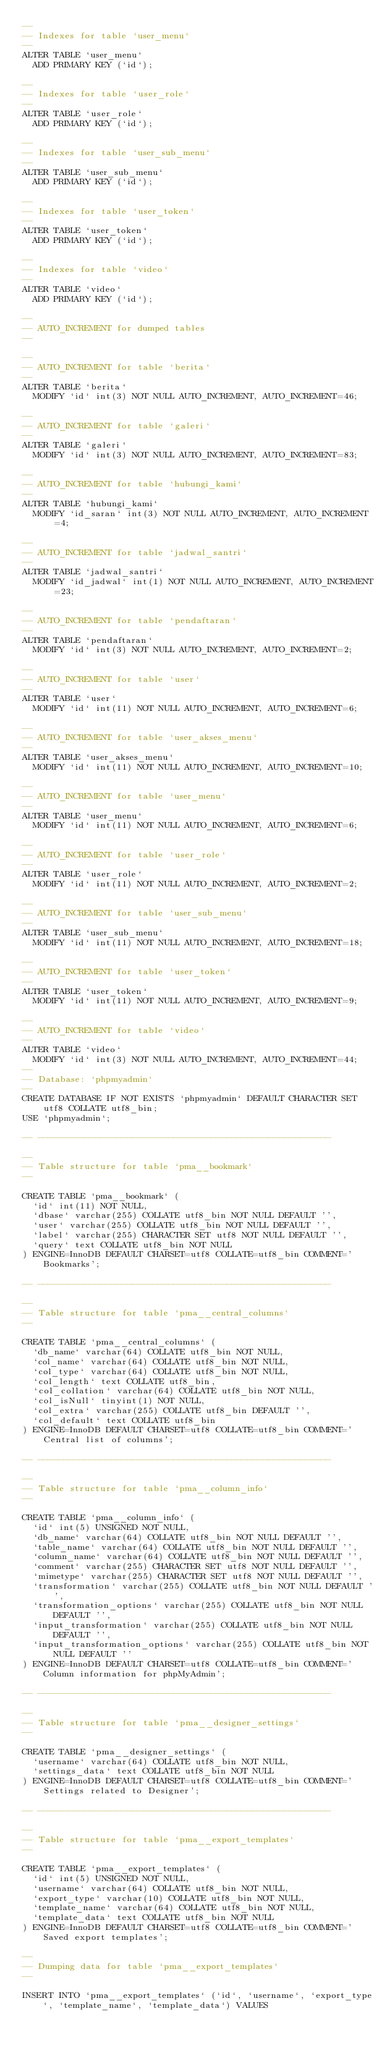<code> <loc_0><loc_0><loc_500><loc_500><_SQL_>--
-- Indexes for table `user_menu`
--
ALTER TABLE `user_menu`
  ADD PRIMARY KEY (`id`);

--
-- Indexes for table `user_role`
--
ALTER TABLE `user_role`
  ADD PRIMARY KEY (`id`);

--
-- Indexes for table `user_sub_menu`
--
ALTER TABLE `user_sub_menu`
  ADD PRIMARY KEY (`id`);

--
-- Indexes for table `user_token`
--
ALTER TABLE `user_token`
  ADD PRIMARY KEY (`id`);

--
-- Indexes for table `video`
--
ALTER TABLE `video`
  ADD PRIMARY KEY (`id`);

--
-- AUTO_INCREMENT for dumped tables
--

--
-- AUTO_INCREMENT for table `berita`
--
ALTER TABLE `berita`
  MODIFY `id` int(3) NOT NULL AUTO_INCREMENT, AUTO_INCREMENT=46;

--
-- AUTO_INCREMENT for table `galeri`
--
ALTER TABLE `galeri`
  MODIFY `id` int(3) NOT NULL AUTO_INCREMENT, AUTO_INCREMENT=83;

--
-- AUTO_INCREMENT for table `hubungi_kami`
--
ALTER TABLE `hubungi_kami`
  MODIFY `id_saran` int(3) NOT NULL AUTO_INCREMENT, AUTO_INCREMENT=4;

--
-- AUTO_INCREMENT for table `jadwal_santri`
--
ALTER TABLE `jadwal_santri`
  MODIFY `id_jadwal` int(1) NOT NULL AUTO_INCREMENT, AUTO_INCREMENT=23;

--
-- AUTO_INCREMENT for table `pendaftaran`
--
ALTER TABLE `pendaftaran`
  MODIFY `id` int(3) NOT NULL AUTO_INCREMENT, AUTO_INCREMENT=2;

--
-- AUTO_INCREMENT for table `user`
--
ALTER TABLE `user`
  MODIFY `id` int(11) NOT NULL AUTO_INCREMENT, AUTO_INCREMENT=6;

--
-- AUTO_INCREMENT for table `user_akses_menu`
--
ALTER TABLE `user_akses_menu`
  MODIFY `id` int(11) NOT NULL AUTO_INCREMENT, AUTO_INCREMENT=10;

--
-- AUTO_INCREMENT for table `user_menu`
--
ALTER TABLE `user_menu`
  MODIFY `id` int(11) NOT NULL AUTO_INCREMENT, AUTO_INCREMENT=6;

--
-- AUTO_INCREMENT for table `user_role`
--
ALTER TABLE `user_role`
  MODIFY `id` int(11) NOT NULL AUTO_INCREMENT, AUTO_INCREMENT=2;

--
-- AUTO_INCREMENT for table `user_sub_menu`
--
ALTER TABLE `user_sub_menu`
  MODIFY `id` int(11) NOT NULL AUTO_INCREMENT, AUTO_INCREMENT=18;

--
-- AUTO_INCREMENT for table `user_token`
--
ALTER TABLE `user_token`
  MODIFY `id` int(11) NOT NULL AUTO_INCREMENT, AUTO_INCREMENT=9;

--
-- AUTO_INCREMENT for table `video`
--
ALTER TABLE `video`
  MODIFY `id` int(3) NOT NULL AUTO_INCREMENT, AUTO_INCREMENT=44;
--
-- Database: `phpmyadmin`
--
CREATE DATABASE IF NOT EXISTS `phpmyadmin` DEFAULT CHARACTER SET utf8 COLLATE utf8_bin;
USE `phpmyadmin`;

-- --------------------------------------------------------

--
-- Table structure for table `pma__bookmark`
--

CREATE TABLE `pma__bookmark` (
  `id` int(11) NOT NULL,
  `dbase` varchar(255) COLLATE utf8_bin NOT NULL DEFAULT '',
  `user` varchar(255) COLLATE utf8_bin NOT NULL DEFAULT '',
  `label` varchar(255) CHARACTER SET utf8 NOT NULL DEFAULT '',
  `query` text COLLATE utf8_bin NOT NULL
) ENGINE=InnoDB DEFAULT CHARSET=utf8 COLLATE=utf8_bin COMMENT='Bookmarks';

-- --------------------------------------------------------

--
-- Table structure for table `pma__central_columns`
--

CREATE TABLE `pma__central_columns` (
  `db_name` varchar(64) COLLATE utf8_bin NOT NULL,
  `col_name` varchar(64) COLLATE utf8_bin NOT NULL,
  `col_type` varchar(64) COLLATE utf8_bin NOT NULL,
  `col_length` text COLLATE utf8_bin,
  `col_collation` varchar(64) COLLATE utf8_bin NOT NULL,
  `col_isNull` tinyint(1) NOT NULL,
  `col_extra` varchar(255) COLLATE utf8_bin DEFAULT '',
  `col_default` text COLLATE utf8_bin
) ENGINE=InnoDB DEFAULT CHARSET=utf8 COLLATE=utf8_bin COMMENT='Central list of columns';

-- --------------------------------------------------------

--
-- Table structure for table `pma__column_info`
--

CREATE TABLE `pma__column_info` (
  `id` int(5) UNSIGNED NOT NULL,
  `db_name` varchar(64) COLLATE utf8_bin NOT NULL DEFAULT '',
  `table_name` varchar(64) COLLATE utf8_bin NOT NULL DEFAULT '',
  `column_name` varchar(64) COLLATE utf8_bin NOT NULL DEFAULT '',
  `comment` varchar(255) CHARACTER SET utf8 NOT NULL DEFAULT '',
  `mimetype` varchar(255) CHARACTER SET utf8 NOT NULL DEFAULT '',
  `transformation` varchar(255) COLLATE utf8_bin NOT NULL DEFAULT '',
  `transformation_options` varchar(255) COLLATE utf8_bin NOT NULL DEFAULT '',
  `input_transformation` varchar(255) COLLATE utf8_bin NOT NULL DEFAULT '',
  `input_transformation_options` varchar(255) COLLATE utf8_bin NOT NULL DEFAULT ''
) ENGINE=InnoDB DEFAULT CHARSET=utf8 COLLATE=utf8_bin COMMENT='Column information for phpMyAdmin';

-- --------------------------------------------------------

--
-- Table structure for table `pma__designer_settings`
--

CREATE TABLE `pma__designer_settings` (
  `username` varchar(64) COLLATE utf8_bin NOT NULL,
  `settings_data` text COLLATE utf8_bin NOT NULL
) ENGINE=InnoDB DEFAULT CHARSET=utf8 COLLATE=utf8_bin COMMENT='Settings related to Designer';

-- --------------------------------------------------------

--
-- Table structure for table `pma__export_templates`
--

CREATE TABLE `pma__export_templates` (
  `id` int(5) UNSIGNED NOT NULL,
  `username` varchar(64) COLLATE utf8_bin NOT NULL,
  `export_type` varchar(10) COLLATE utf8_bin NOT NULL,
  `template_name` varchar(64) COLLATE utf8_bin NOT NULL,
  `template_data` text COLLATE utf8_bin NOT NULL
) ENGINE=InnoDB DEFAULT CHARSET=utf8 COLLATE=utf8_bin COMMENT='Saved export templates';

--
-- Dumping data for table `pma__export_templates`
--

INSERT INTO `pma__export_templates` (`id`, `username`, `export_type`, `template_name`, `template_data`) VALUES</code> 